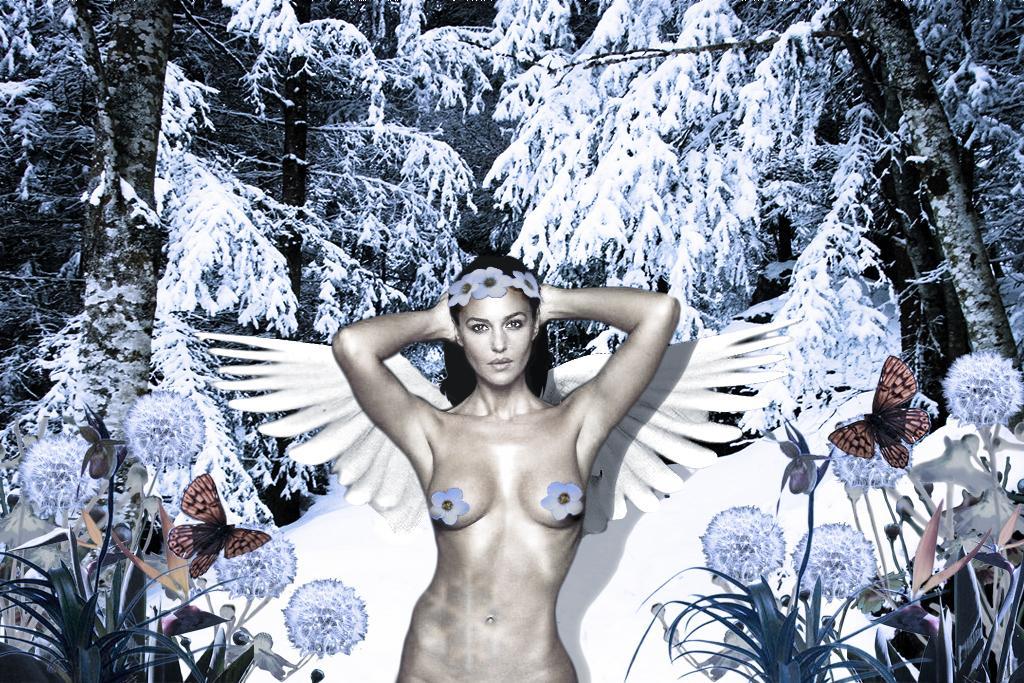Describe this image in one or two sentences. It is an edited image. In this image we can see the nude woman. We can also see the plants, flowers, butterflies and also the trees which are fully covered with the snow. 